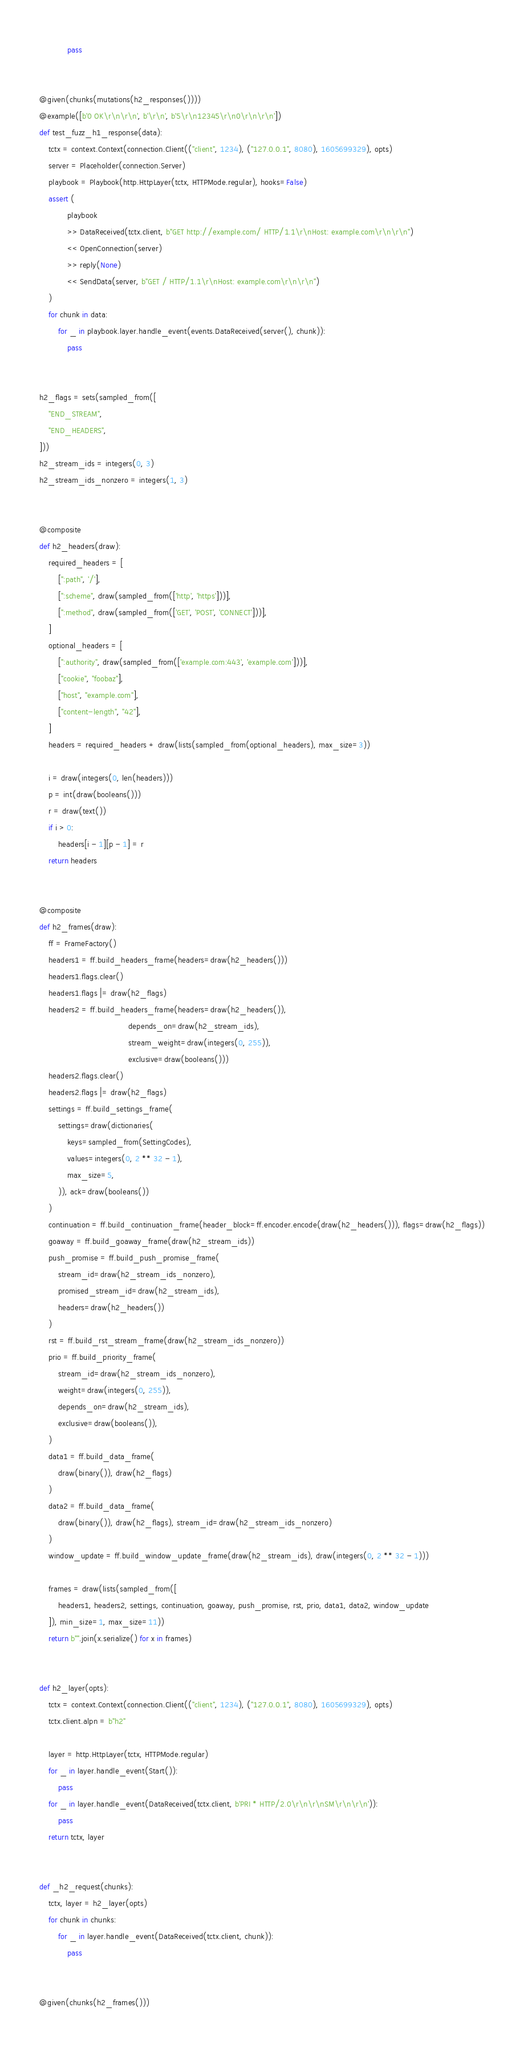Convert code to text. <code><loc_0><loc_0><loc_500><loc_500><_Python_>            pass


@given(chunks(mutations(h2_responses())))
@example([b'0 OK\r\n\r\n', b'\r\n', b'5\r\n12345\r\n0\r\n\r\n'])
def test_fuzz_h1_response(data):
    tctx = context.Context(connection.Client(("client", 1234), ("127.0.0.1", 8080), 1605699329), opts)
    server = Placeholder(connection.Server)
    playbook = Playbook(http.HttpLayer(tctx, HTTPMode.regular), hooks=False)
    assert (
            playbook
            >> DataReceived(tctx.client, b"GET http://example.com/ HTTP/1.1\r\nHost: example.com\r\n\r\n")
            << OpenConnection(server)
            >> reply(None)
            << SendData(server, b"GET / HTTP/1.1\r\nHost: example.com\r\n\r\n")
    )
    for chunk in data:
        for _ in playbook.layer.handle_event(events.DataReceived(server(), chunk)):
            pass


h2_flags = sets(sampled_from([
    "END_STREAM",
    "END_HEADERS",
]))
h2_stream_ids = integers(0, 3)
h2_stream_ids_nonzero = integers(1, 3)


@composite
def h2_headers(draw):
    required_headers = [
        [":path", '/'],
        [":scheme", draw(sampled_from(['http', 'https']))],
        [":method", draw(sampled_from(['GET', 'POST', 'CONNECT']))],
    ]
    optional_headers = [
        [":authority", draw(sampled_from(['example.com:443', 'example.com']))],
        ["cookie", "foobaz"],
        ["host", "example.com"],
        ["content-length", "42"],
    ]
    headers = required_headers + draw(lists(sampled_from(optional_headers), max_size=3))

    i = draw(integers(0, len(headers)))
    p = int(draw(booleans()))
    r = draw(text())
    if i > 0:
        headers[i - 1][p - 1] = r
    return headers


@composite
def h2_frames(draw):
    ff = FrameFactory()
    headers1 = ff.build_headers_frame(headers=draw(h2_headers()))
    headers1.flags.clear()
    headers1.flags |= draw(h2_flags)
    headers2 = ff.build_headers_frame(headers=draw(h2_headers()),
                                      depends_on=draw(h2_stream_ids),
                                      stream_weight=draw(integers(0, 255)),
                                      exclusive=draw(booleans()))
    headers2.flags.clear()
    headers2.flags |= draw(h2_flags)
    settings = ff.build_settings_frame(
        settings=draw(dictionaries(
            keys=sampled_from(SettingCodes),
            values=integers(0, 2 ** 32 - 1),
            max_size=5,
        )), ack=draw(booleans())
    )
    continuation = ff.build_continuation_frame(header_block=ff.encoder.encode(draw(h2_headers())), flags=draw(h2_flags))
    goaway = ff.build_goaway_frame(draw(h2_stream_ids))
    push_promise = ff.build_push_promise_frame(
        stream_id=draw(h2_stream_ids_nonzero),
        promised_stream_id=draw(h2_stream_ids),
        headers=draw(h2_headers())
    )
    rst = ff.build_rst_stream_frame(draw(h2_stream_ids_nonzero))
    prio = ff.build_priority_frame(
        stream_id=draw(h2_stream_ids_nonzero),
        weight=draw(integers(0, 255)),
        depends_on=draw(h2_stream_ids),
        exclusive=draw(booleans()),
    )
    data1 = ff.build_data_frame(
        draw(binary()), draw(h2_flags)
    )
    data2 = ff.build_data_frame(
        draw(binary()), draw(h2_flags), stream_id=draw(h2_stream_ids_nonzero)
    )
    window_update = ff.build_window_update_frame(draw(h2_stream_ids), draw(integers(0, 2 ** 32 - 1)))

    frames = draw(lists(sampled_from([
        headers1, headers2, settings, continuation, goaway, push_promise, rst, prio, data1, data2, window_update
    ]), min_size=1, max_size=11))
    return b"".join(x.serialize() for x in frames)


def h2_layer(opts):
    tctx = context.Context(connection.Client(("client", 1234), ("127.0.0.1", 8080), 1605699329), opts)
    tctx.client.alpn = b"h2"

    layer = http.HttpLayer(tctx, HTTPMode.regular)
    for _ in layer.handle_event(Start()):
        pass
    for _ in layer.handle_event(DataReceived(tctx.client, b'PRI * HTTP/2.0\r\n\r\nSM\r\n\r\n')):
        pass
    return tctx, layer


def _h2_request(chunks):
    tctx, layer = h2_layer(opts)
    for chunk in chunks:
        for _ in layer.handle_event(DataReceived(tctx.client, chunk)):
            pass


@given(chunks(h2_frames()))</code> 